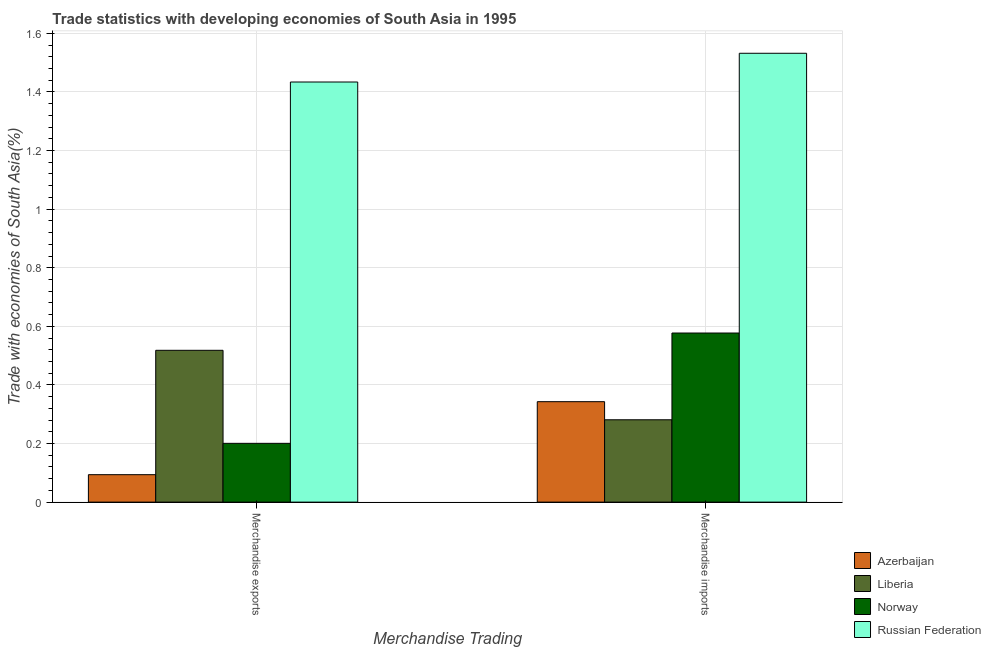How many groups of bars are there?
Provide a short and direct response. 2. What is the merchandise exports in Azerbaijan?
Offer a terse response. 0.09. Across all countries, what is the maximum merchandise imports?
Offer a terse response. 1.53. Across all countries, what is the minimum merchandise exports?
Offer a very short reply. 0.09. In which country was the merchandise exports maximum?
Provide a succinct answer. Russian Federation. In which country was the merchandise exports minimum?
Offer a terse response. Azerbaijan. What is the total merchandise imports in the graph?
Ensure brevity in your answer.  2.73. What is the difference between the merchandise exports in Norway and that in Azerbaijan?
Give a very brief answer. 0.11. What is the difference between the merchandise imports in Liberia and the merchandise exports in Russian Federation?
Your answer should be compact. -1.15. What is the average merchandise imports per country?
Offer a very short reply. 0.68. What is the difference between the merchandise exports and merchandise imports in Russian Federation?
Keep it short and to the point. -0.1. In how many countries, is the merchandise exports greater than 0.56 %?
Your answer should be compact. 1. What is the ratio of the merchandise exports in Russian Federation to that in Liberia?
Keep it short and to the point. 2.77. What does the 3rd bar from the left in Merchandise imports represents?
Provide a succinct answer. Norway. What does the 4th bar from the right in Merchandise exports represents?
Provide a short and direct response. Azerbaijan. How many bars are there?
Your answer should be compact. 8. Are all the bars in the graph horizontal?
Give a very brief answer. No. How many countries are there in the graph?
Provide a succinct answer. 4. Does the graph contain grids?
Keep it short and to the point. Yes. Where does the legend appear in the graph?
Your response must be concise. Bottom right. How many legend labels are there?
Your response must be concise. 4. How are the legend labels stacked?
Provide a succinct answer. Vertical. What is the title of the graph?
Your answer should be compact. Trade statistics with developing economies of South Asia in 1995. What is the label or title of the X-axis?
Your answer should be compact. Merchandise Trading. What is the label or title of the Y-axis?
Your answer should be very brief. Trade with economies of South Asia(%). What is the Trade with economies of South Asia(%) in Azerbaijan in Merchandise exports?
Your response must be concise. 0.09. What is the Trade with economies of South Asia(%) in Liberia in Merchandise exports?
Your answer should be compact. 0.52. What is the Trade with economies of South Asia(%) of Norway in Merchandise exports?
Provide a short and direct response. 0.2. What is the Trade with economies of South Asia(%) in Russian Federation in Merchandise exports?
Your answer should be compact. 1.43. What is the Trade with economies of South Asia(%) of Azerbaijan in Merchandise imports?
Give a very brief answer. 0.34. What is the Trade with economies of South Asia(%) of Liberia in Merchandise imports?
Your response must be concise. 0.28. What is the Trade with economies of South Asia(%) in Norway in Merchandise imports?
Give a very brief answer. 0.58. What is the Trade with economies of South Asia(%) of Russian Federation in Merchandise imports?
Give a very brief answer. 1.53. Across all Merchandise Trading, what is the maximum Trade with economies of South Asia(%) in Azerbaijan?
Give a very brief answer. 0.34. Across all Merchandise Trading, what is the maximum Trade with economies of South Asia(%) in Liberia?
Ensure brevity in your answer.  0.52. Across all Merchandise Trading, what is the maximum Trade with economies of South Asia(%) in Norway?
Your response must be concise. 0.58. Across all Merchandise Trading, what is the maximum Trade with economies of South Asia(%) in Russian Federation?
Provide a short and direct response. 1.53. Across all Merchandise Trading, what is the minimum Trade with economies of South Asia(%) in Azerbaijan?
Your answer should be very brief. 0.09. Across all Merchandise Trading, what is the minimum Trade with economies of South Asia(%) in Liberia?
Offer a terse response. 0.28. Across all Merchandise Trading, what is the minimum Trade with economies of South Asia(%) of Norway?
Give a very brief answer. 0.2. Across all Merchandise Trading, what is the minimum Trade with economies of South Asia(%) in Russian Federation?
Offer a very short reply. 1.43. What is the total Trade with economies of South Asia(%) in Azerbaijan in the graph?
Provide a short and direct response. 0.44. What is the total Trade with economies of South Asia(%) of Liberia in the graph?
Give a very brief answer. 0.8. What is the total Trade with economies of South Asia(%) in Russian Federation in the graph?
Ensure brevity in your answer.  2.97. What is the difference between the Trade with economies of South Asia(%) of Azerbaijan in Merchandise exports and that in Merchandise imports?
Your answer should be very brief. -0.25. What is the difference between the Trade with economies of South Asia(%) of Liberia in Merchandise exports and that in Merchandise imports?
Provide a succinct answer. 0.24. What is the difference between the Trade with economies of South Asia(%) in Norway in Merchandise exports and that in Merchandise imports?
Your response must be concise. -0.38. What is the difference between the Trade with economies of South Asia(%) in Russian Federation in Merchandise exports and that in Merchandise imports?
Keep it short and to the point. -0.1. What is the difference between the Trade with economies of South Asia(%) in Azerbaijan in Merchandise exports and the Trade with economies of South Asia(%) in Liberia in Merchandise imports?
Keep it short and to the point. -0.19. What is the difference between the Trade with economies of South Asia(%) of Azerbaijan in Merchandise exports and the Trade with economies of South Asia(%) of Norway in Merchandise imports?
Ensure brevity in your answer.  -0.48. What is the difference between the Trade with economies of South Asia(%) in Azerbaijan in Merchandise exports and the Trade with economies of South Asia(%) in Russian Federation in Merchandise imports?
Your answer should be compact. -1.44. What is the difference between the Trade with economies of South Asia(%) of Liberia in Merchandise exports and the Trade with economies of South Asia(%) of Norway in Merchandise imports?
Make the answer very short. -0.06. What is the difference between the Trade with economies of South Asia(%) of Liberia in Merchandise exports and the Trade with economies of South Asia(%) of Russian Federation in Merchandise imports?
Ensure brevity in your answer.  -1.01. What is the difference between the Trade with economies of South Asia(%) of Norway in Merchandise exports and the Trade with economies of South Asia(%) of Russian Federation in Merchandise imports?
Provide a short and direct response. -1.33. What is the average Trade with economies of South Asia(%) of Azerbaijan per Merchandise Trading?
Offer a very short reply. 0.22. What is the average Trade with economies of South Asia(%) in Liberia per Merchandise Trading?
Your response must be concise. 0.4. What is the average Trade with economies of South Asia(%) of Norway per Merchandise Trading?
Keep it short and to the point. 0.39. What is the average Trade with economies of South Asia(%) of Russian Federation per Merchandise Trading?
Provide a short and direct response. 1.48. What is the difference between the Trade with economies of South Asia(%) of Azerbaijan and Trade with economies of South Asia(%) of Liberia in Merchandise exports?
Provide a succinct answer. -0.42. What is the difference between the Trade with economies of South Asia(%) of Azerbaijan and Trade with economies of South Asia(%) of Norway in Merchandise exports?
Offer a very short reply. -0.11. What is the difference between the Trade with economies of South Asia(%) in Azerbaijan and Trade with economies of South Asia(%) in Russian Federation in Merchandise exports?
Offer a very short reply. -1.34. What is the difference between the Trade with economies of South Asia(%) of Liberia and Trade with economies of South Asia(%) of Norway in Merchandise exports?
Your answer should be very brief. 0.32. What is the difference between the Trade with economies of South Asia(%) in Liberia and Trade with economies of South Asia(%) in Russian Federation in Merchandise exports?
Keep it short and to the point. -0.92. What is the difference between the Trade with economies of South Asia(%) in Norway and Trade with economies of South Asia(%) in Russian Federation in Merchandise exports?
Keep it short and to the point. -1.23. What is the difference between the Trade with economies of South Asia(%) in Azerbaijan and Trade with economies of South Asia(%) in Liberia in Merchandise imports?
Your answer should be very brief. 0.06. What is the difference between the Trade with economies of South Asia(%) in Azerbaijan and Trade with economies of South Asia(%) in Norway in Merchandise imports?
Give a very brief answer. -0.23. What is the difference between the Trade with economies of South Asia(%) in Azerbaijan and Trade with economies of South Asia(%) in Russian Federation in Merchandise imports?
Provide a succinct answer. -1.19. What is the difference between the Trade with economies of South Asia(%) of Liberia and Trade with economies of South Asia(%) of Norway in Merchandise imports?
Ensure brevity in your answer.  -0.3. What is the difference between the Trade with economies of South Asia(%) in Liberia and Trade with economies of South Asia(%) in Russian Federation in Merchandise imports?
Offer a very short reply. -1.25. What is the difference between the Trade with economies of South Asia(%) of Norway and Trade with economies of South Asia(%) of Russian Federation in Merchandise imports?
Offer a terse response. -0.95. What is the ratio of the Trade with economies of South Asia(%) in Azerbaijan in Merchandise exports to that in Merchandise imports?
Your answer should be compact. 0.27. What is the ratio of the Trade with economies of South Asia(%) of Liberia in Merchandise exports to that in Merchandise imports?
Your answer should be compact. 1.84. What is the ratio of the Trade with economies of South Asia(%) of Norway in Merchandise exports to that in Merchandise imports?
Make the answer very short. 0.35. What is the ratio of the Trade with economies of South Asia(%) of Russian Federation in Merchandise exports to that in Merchandise imports?
Provide a succinct answer. 0.94. What is the difference between the highest and the second highest Trade with economies of South Asia(%) of Azerbaijan?
Your answer should be compact. 0.25. What is the difference between the highest and the second highest Trade with economies of South Asia(%) of Liberia?
Offer a very short reply. 0.24. What is the difference between the highest and the second highest Trade with economies of South Asia(%) of Norway?
Ensure brevity in your answer.  0.38. What is the difference between the highest and the second highest Trade with economies of South Asia(%) in Russian Federation?
Provide a succinct answer. 0.1. What is the difference between the highest and the lowest Trade with economies of South Asia(%) in Azerbaijan?
Ensure brevity in your answer.  0.25. What is the difference between the highest and the lowest Trade with economies of South Asia(%) in Liberia?
Your answer should be very brief. 0.24. What is the difference between the highest and the lowest Trade with economies of South Asia(%) of Norway?
Give a very brief answer. 0.38. What is the difference between the highest and the lowest Trade with economies of South Asia(%) of Russian Federation?
Provide a succinct answer. 0.1. 